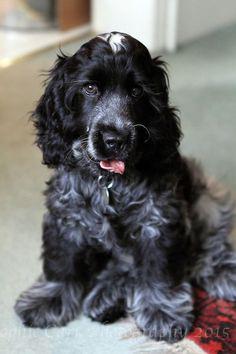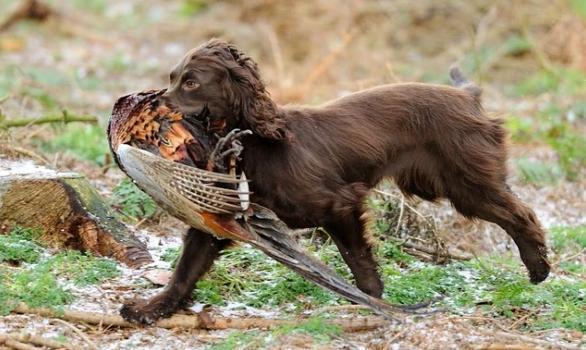The first image is the image on the left, the second image is the image on the right. Analyze the images presented: Is the assertion "One image shows a black-and-gray spaniel sitting upright, and the other image shows a brown spaniel holding a game bird in its mouth." valid? Answer yes or no. Yes. The first image is the image on the left, the second image is the image on the right. Evaluate the accuracy of this statement regarding the images: "An image contains a dog with a dead bird in its mouth.". Is it true? Answer yes or no. Yes. 